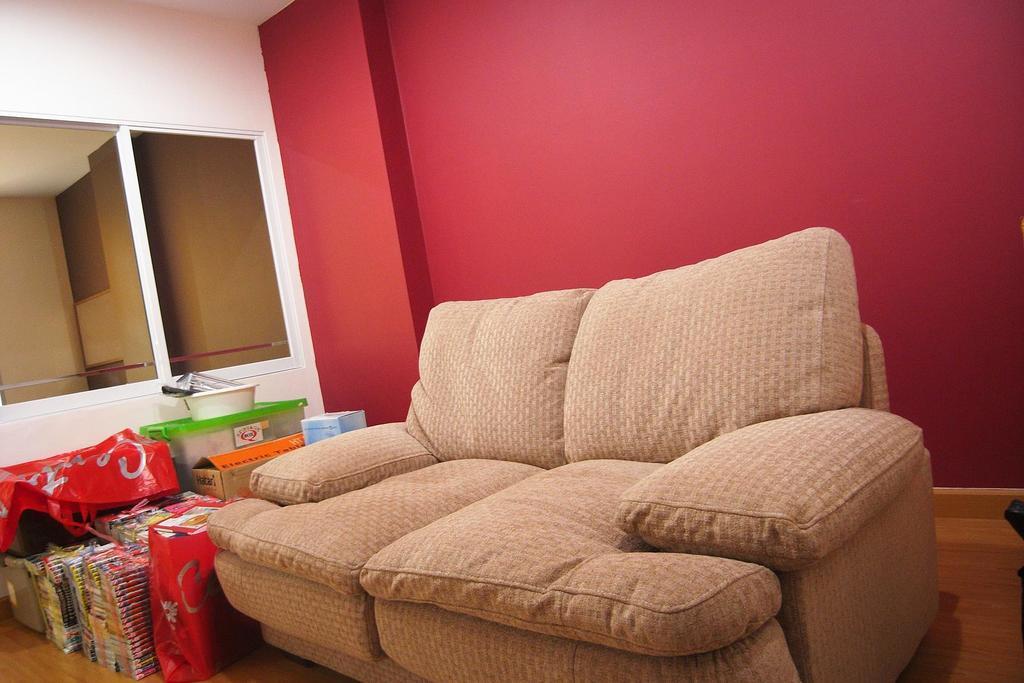Could you give a brief overview of what you see in this image? In the image we can see there is a sofa and behind the sofa there is a red colour wall and beside the sofa there are cover in which books are kept and the boxes. 